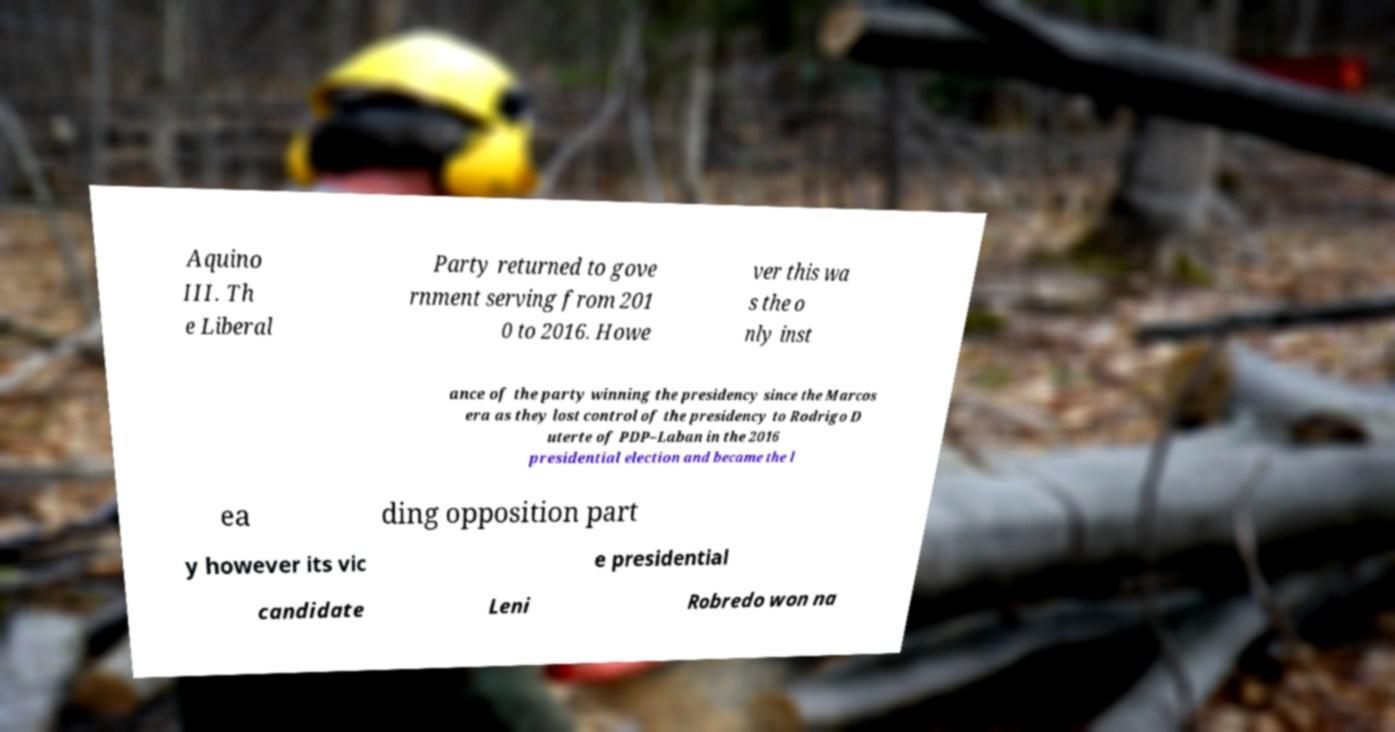Please identify and transcribe the text found in this image. Aquino III. Th e Liberal Party returned to gove rnment serving from 201 0 to 2016. Howe ver this wa s the o nly inst ance of the party winning the presidency since the Marcos era as they lost control of the presidency to Rodrigo D uterte of PDP–Laban in the 2016 presidential election and became the l ea ding opposition part y however its vic e presidential candidate Leni Robredo won na 